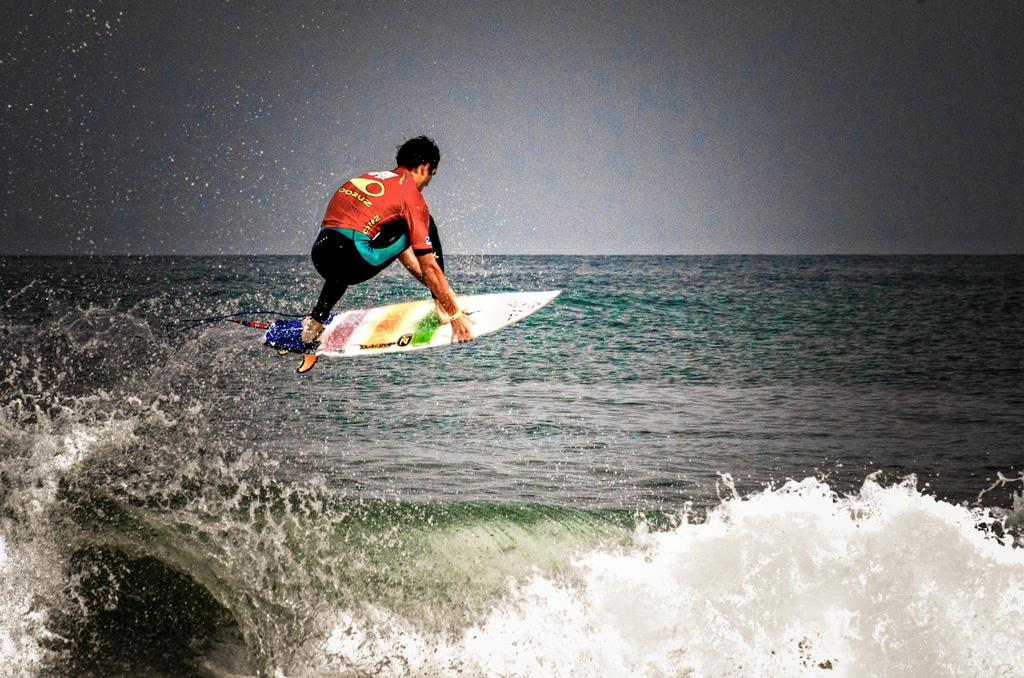What activity is the person in the image engaged in? There is a person on a waterboard in the image. What is present in the image besides the person on the waterboard? Water is visible in the image. What can be seen at the top of the image? The sky is visible at the top of the image. What type of feast is being prepared in the image? There is no feast present in the image; it features a person on a waterboard with water and the sky visible. How much wealth is visible in the image? There is no indication of wealth in the image; it focuses on the person on the waterboard, water, and the sky. 